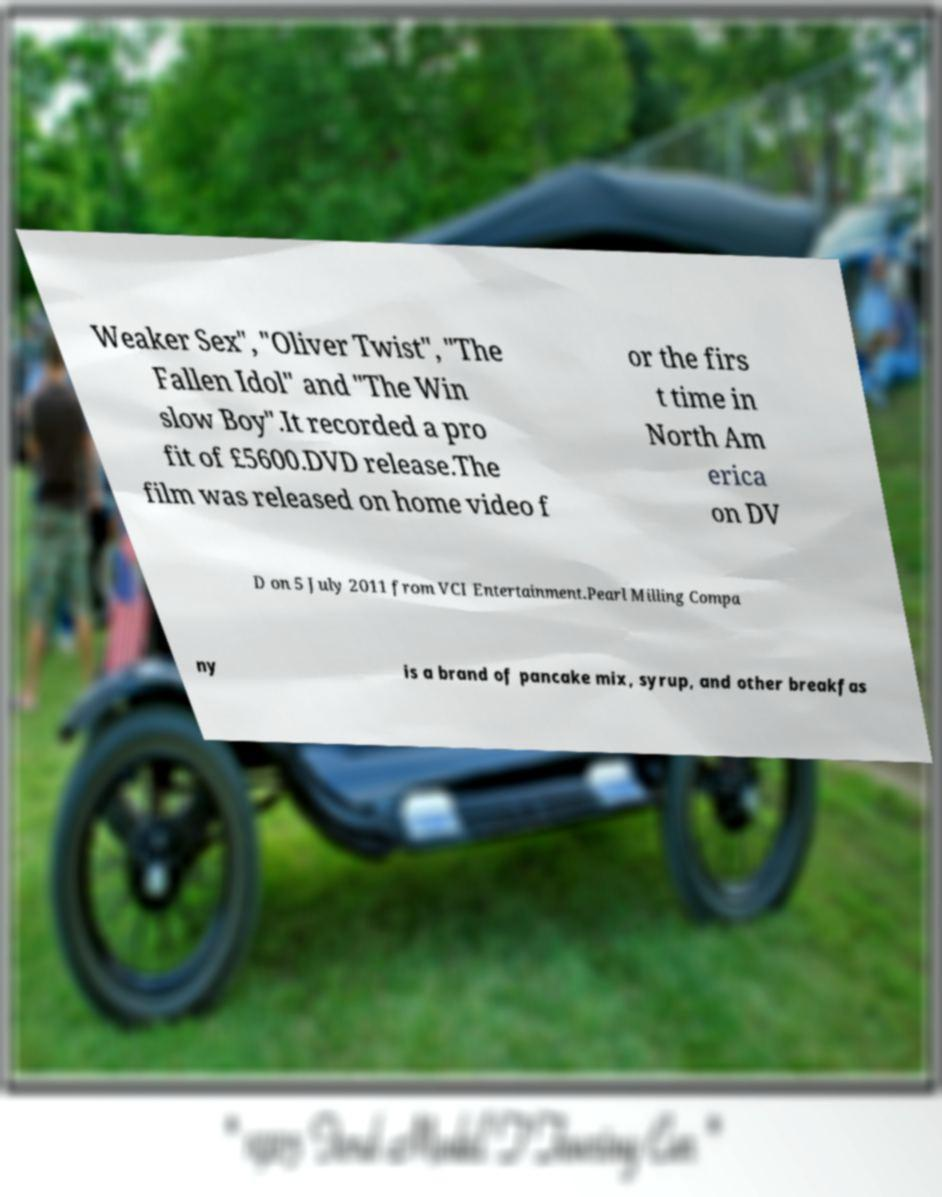Please read and relay the text visible in this image. What does it say? Weaker Sex", "Oliver Twist", "The Fallen Idol" and "The Win slow Boy".It recorded a pro fit of £5600.DVD release.The film was released on home video f or the firs t time in North Am erica on DV D on 5 July 2011 from VCI Entertainment.Pearl Milling Compa ny is a brand of pancake mix, syrup, and other breakfas 